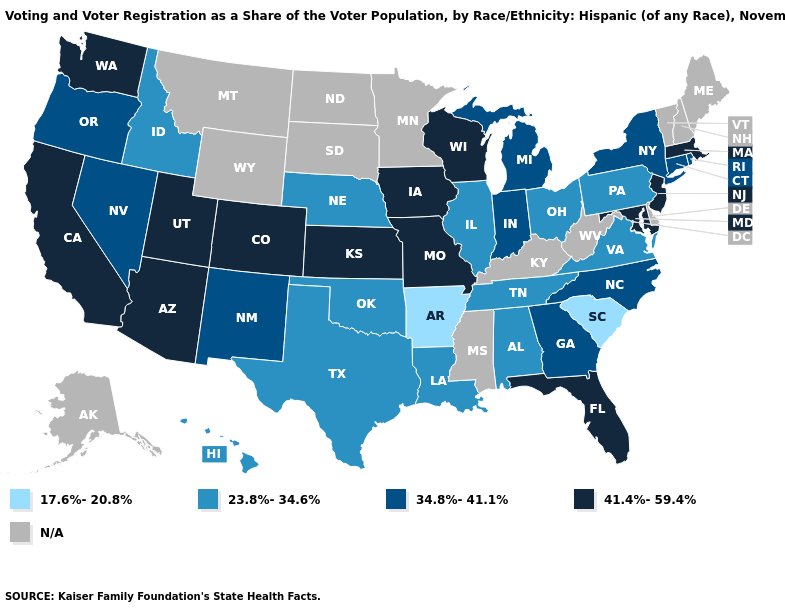Among the states that border Kansas , which have the highest value?
Write a very short answer. Colorado, Missouri. Does Arkansas have the lowest value in the USA?
Keep it brief. Yes. What is the value of Washington?
Give a very brief answer. 41.4%-59.4%. What is the value of Connecticut?
Be succinct. 34.8%-41.1%. Name the states that have a value in the range 17.6%-20.8%?
Concise answer only. Arkansas, South Carolina. Is the legend a continuous bar?
Write a very short answer. No. Which states have the lowest value in the USA?
Short answer required. Arkansas, South Carolina. What is the value of Texas?
Quick response, please. 23.8%-34.6%. Does New York have the lowest value in the Northeast?
Keep it brief. No. Name the states that have a value in the range 17.6%-20.8%?
Write a very short answer. Arkansas, South Carolina. Among the states that border Indiana , does Ohio have the highest value?
Keep it brief. No. What is the value of Pennsylvania?
Answer briefly. 23.8%-34.6%. 